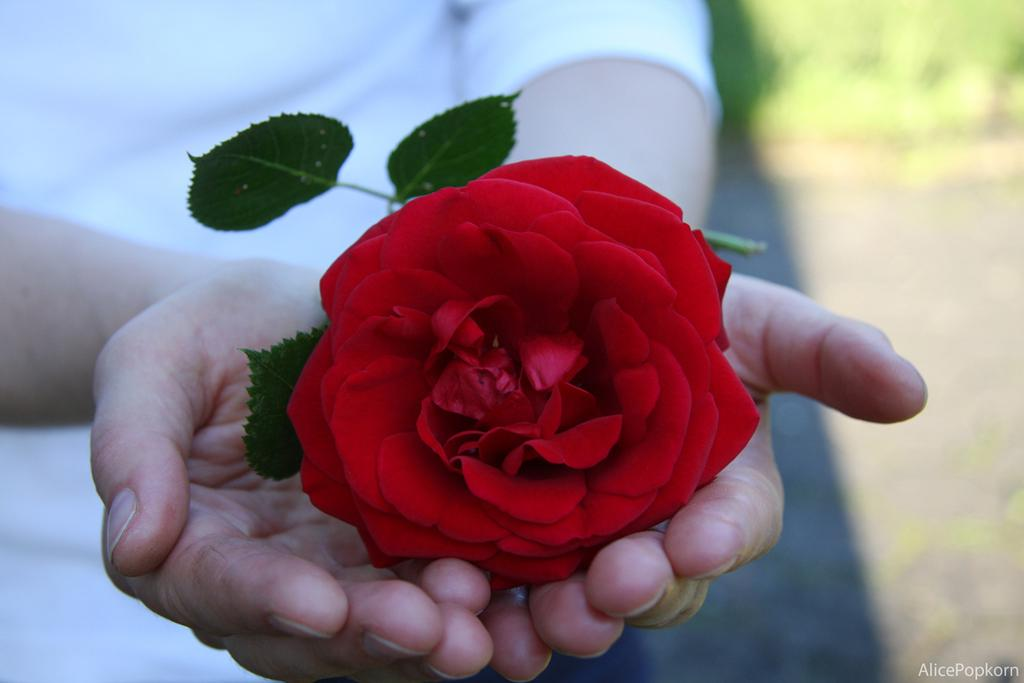What is the main subject of the picture? There is a human in the picture. What is the human holding in the picture? The human is holding a rose flower. Can you describe any additional elements in the picture? There is a watermark in the bottom right corner of the picture. What is the human discussing with the rose flower in the picture? There is no indication in the image that the human is having a discussion with the rose flower. 